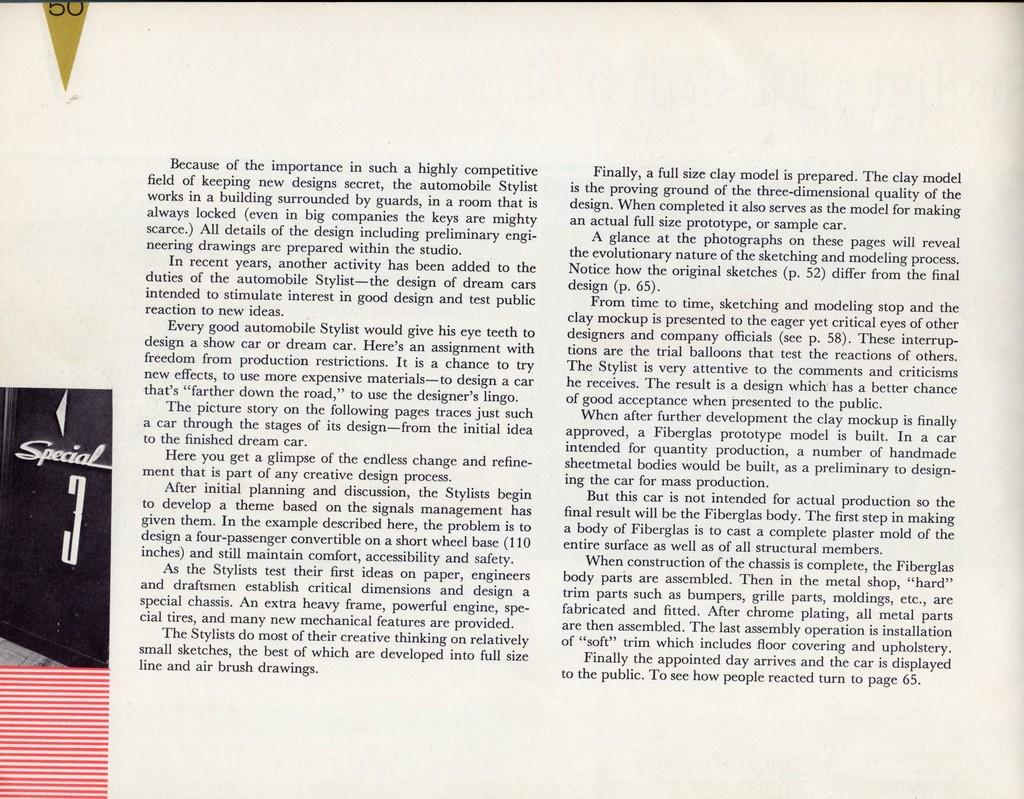What is the third paragraph about?
Make the answer very short. Designing a dream car. What is the last number on the page?
Offer a terse response. 65. 